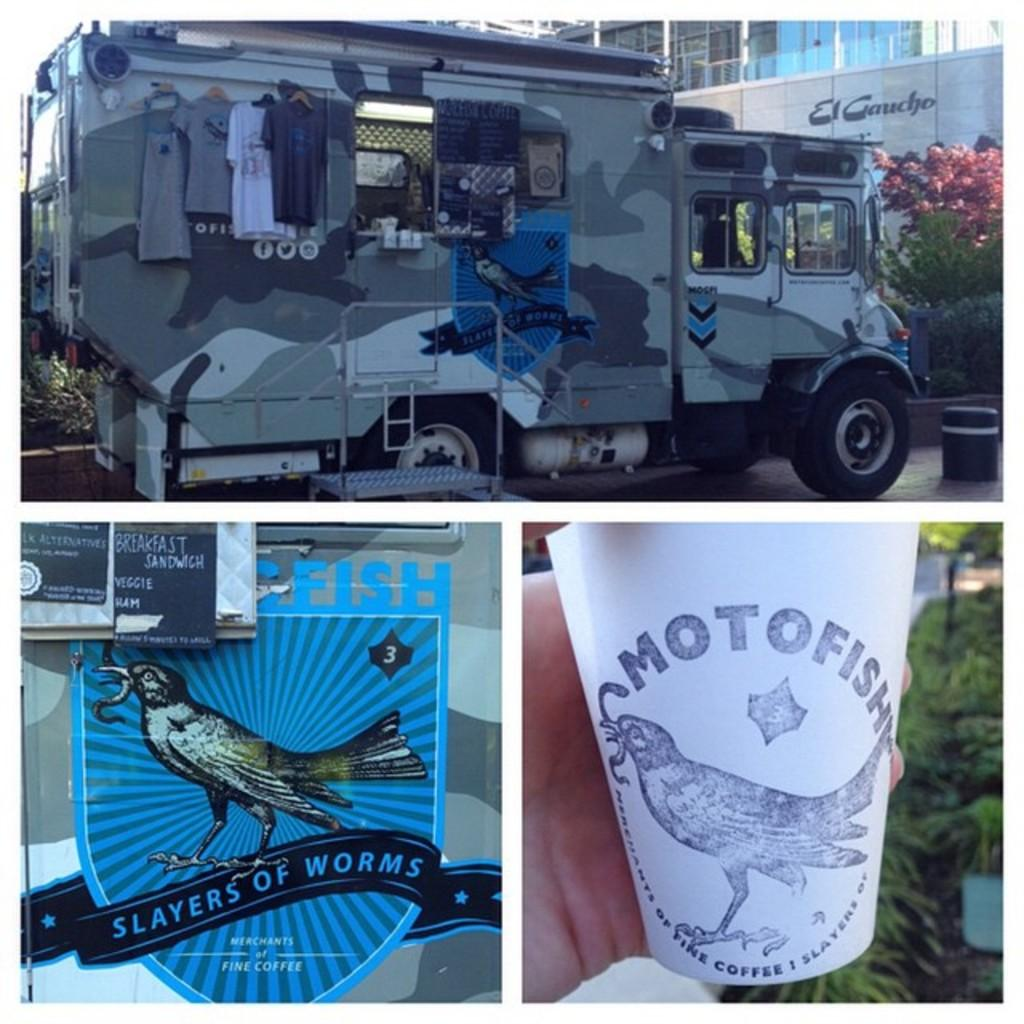<image>
Provide a brief description of the given image. A merchandise truck set up with a sign that says Slayers of Worms on it. 